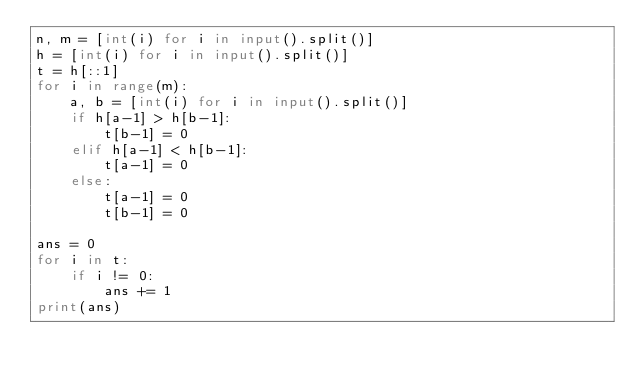<code> <loc_0><loc_0><loc_500><loc_500><_Python_>n, m = [int(i) for i in input().split()]
h = [int(i) for i in input().split()]
t = h[::1]
for i in range(m):
    a, b = [int(i) for i in input().split()]
    if h[a-1] > h[b-1]:
        t[b-1] = 0
    elif h[a-1] < h[b-1]:
        t[a-1] = 0
    else:
        t[a-1] = 0
        t[b-1] = 0

ans = 0
for i in t:
    if i != 0:
        ans += 1
print(ans)</code> 